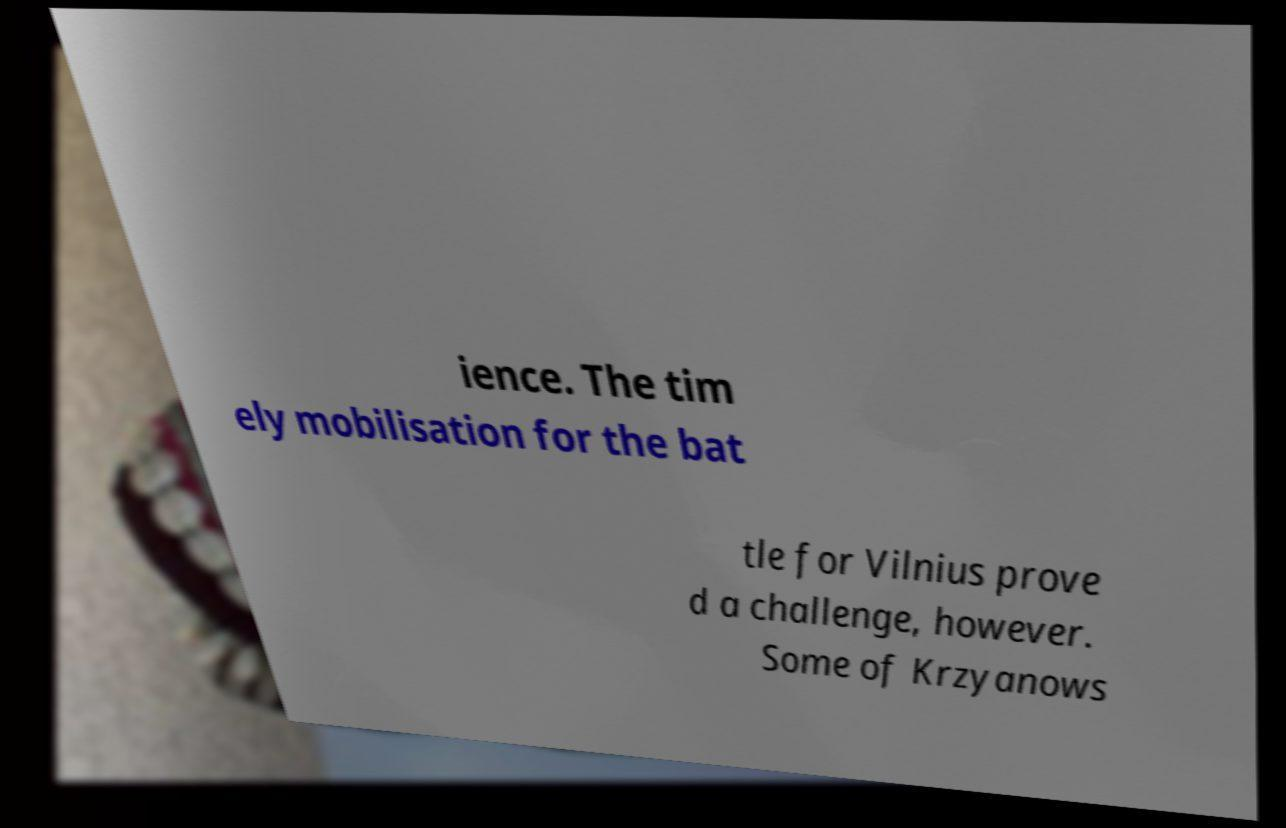Could you extract and type out the text from this image? ience. The tim ely mobilisation for the bat tle for Vilnius prove d a challenge, however. Some of Krzyanows 